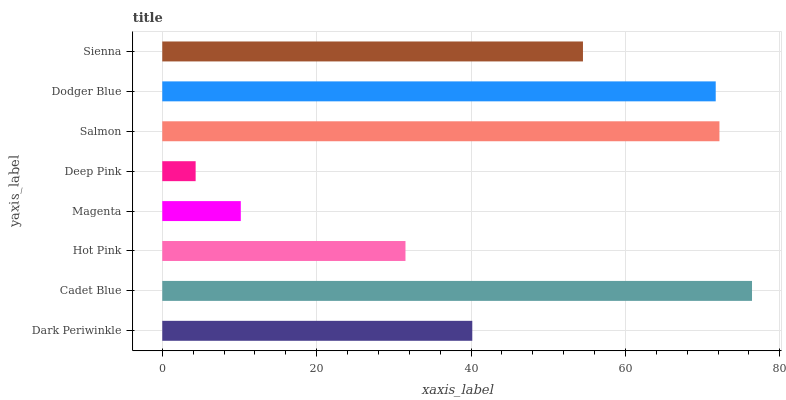Is Deep Pink the minimum?
Answer yes or no. Yes. Is Cadet Blue the maximum?
Answer yes or no. Yes. Is Hot Pink the minimum?
Answer yes or no. No. Is Hot Pink the maximum?
Answer yes or no. No. Is Cadet Blue greater than Hot Pink?
Answer yes or no. Yes. Is Hot Pink less than Cadet Blue?
Answer yes or no. Yes. Is Hot Pink greater than Cadet Blue?
Answer yes or no. No. Is Cadet Blue less than Hot Pink?
Answer yes or no. No. Is Sienna the high median?
Answer yes or no. Yes. Is Dark Periwinkle the low median?
Answer yes or no. Yes. Is Deep Pink the high median?
Answer yes or no. No. Is Sienna the low median?
Answer yes or no. No. 